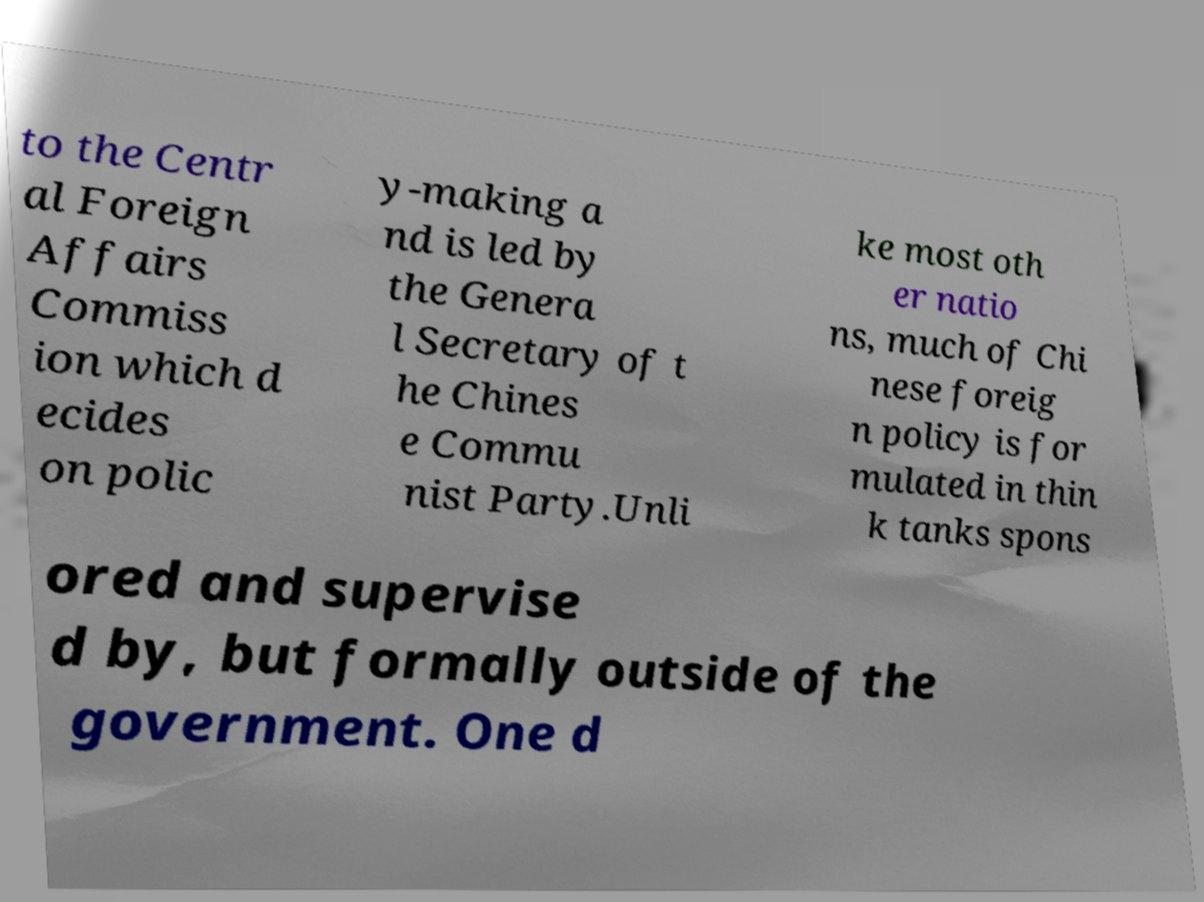What messages or text are displayed in this image? I need them in a readable, typed format. to the Centr al Foreign Affairs Commiss ion which d ecides on polic y-making a nd is led by the Genera l Secretary of t he Chines e Commu nist Party.Unli ke most oth er natio ns, much of Chi nese foreig n policy is for mulated in thin k tanks spons ored and supervise d by, but formally outside of the government. One d 